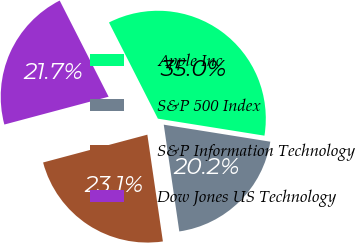Convert chart. <chart><loc_0><loc_0><loc_500><loc_500><pie_chart><fcel>Apple Inc<fcel>S&P 500 Index<fcel>S&P Information Technology<fcel>Dow Jones US Technology<nl><fcel>35.01%<fcel>20.18%<fcel>23.15%<fcel>21.66%<nl></chart> 